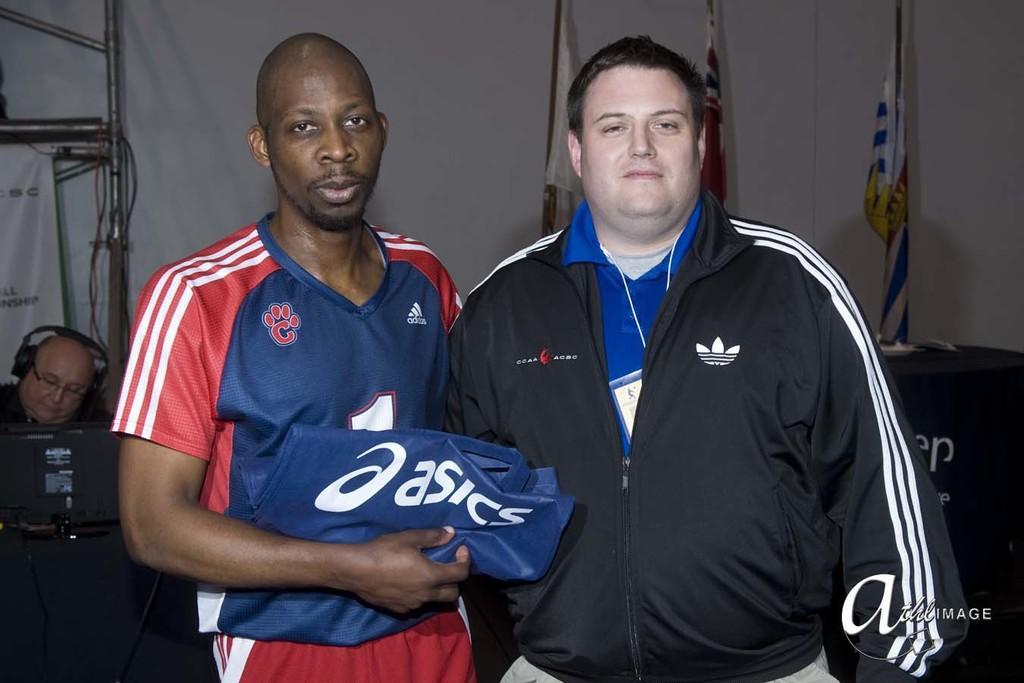Please provide a concise description of this image. In this image there are two persons in which one of them is holding a dress, there are a few flags on the table, there is person with goggles and a headset, a computer, few poles, cables, a banner and a white color cloth. 